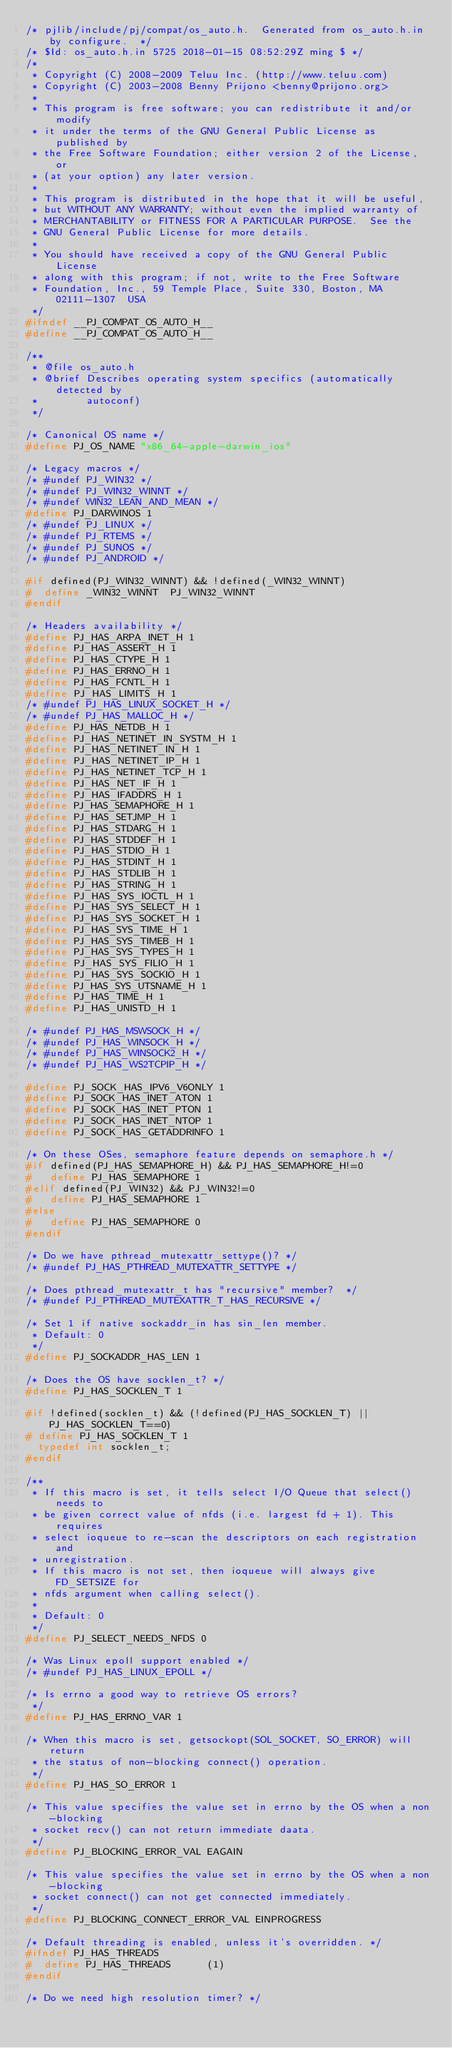<code> <loc_0><loc_0><loc_500><loc_500><_C_>/* pjlib/include/pj/compat/os_auto.h.  Generated from os_auto.h.in by configure.  */
/* $Id: os_auto.h.in 5725 2018-01-15 08:52:29Z ming $ */
/* 
 * Copyright (C) 2008-2009 Teluu Inc. (http://www.teluu.com)
 * Copyright (C) 2003-2008 Benny Prijono <benny@prijono.org>
 *
 * This program is free software; you can redistribute it and/or modify
 * it under the terms of the GNU General Public License as published by
 * the Free Software Foundation; either version 2 of the License, or
 * (at your option) any later version.
 *
 * This program is distributed in the hope that it will be useful,
 * but WITHOUT ANY WARRANTY; without even the implied warranty of
 * MERCHANTABILITY or FITNESS FOR A PARTICULAR PURPOSE.  See the
 * GNU General Public License for more details.
 *
 * You should have received a copy of the GNU General Public License
 * along with this program; if not, write to the Free Software
 * Foundation, Inc., 59 Temple Place, Suite 330, Boston, MA  02111-1307  USA 
 */
#ifndef __PJ_COMPAT_OS_AUTO_H__
#define __PJ_COMPAT_OS_AUTO_H__

/**
 * @file os_auto.h
 * @brief Describes operating system specifics (automatically detected by
 *        autoconf)
 */

/* Canonical OS name */
#define PJ_OS_NAME "x86_64-apple-darwin_ios"

/* Legacy macros */
/* #undef PJ_WIN32 */
/* #undef PJ_WIN32_WINNT */
/* #undef WIN32_LEAN_AND_MEAN */
#define PJ_DARWINOS 1
/* #undef PJ_LINUX */
/* #undef PJ_RTEMS */
/* #undef PJ_SUNOS */
/* #undef PJ_ANDROID */

#if defined(PJ_WIN32_WINNT) && !defined(_WIN32_WINNT)
#  define _WIN32_WINNT	PJ_WIN32_WINNT
#endif

/* Headers availability */
#define PJ_HAS_ARPA_INET_H 1
#define PJ_HAS_ASSERT_H 1
#define PJ_HAS_CTYPE_H 1
#define PJ_HAS_ERRNO_H 1
#define PJ_HAS_FCNTL_H 1
#define PJ_HAS_LIMITS_H 1
/* #undef PJ_HAS_LINUX_SOCKET_H */
/* #undef PJ_HAS_MALLOC_H */
#define PJ_HAS_NETDB_H 1
#define PJ_HAS_NETINET_IN_SYSTM_H 1
#define PJ_HAS_NETINET_IN_H 1
#define PJ_HAS_NETINET_IP_H 1
#define PJ_HAS_NETINET_TCP_H 1
#define PJ_HAS_NET_IF_H 1
#define PJ_HAS_IFADDRS_H 1
#define PJ_HAS_SEMAPHORE_H 1
#define PJ_HAS_SETJMP_H 1
#define PJ_HAS_STDARG_H 1
#define PJ_HAS_STDDEF_H 1
#define PJ_HAS_STDIO_H 1
#define PJ_HAS_STDINT_H 1
#define PJ_HAS_STDLIB_H 1
#define PJ_HAS_STRING_H 1
#define PJ_HAS_SYS_IOCTL_H 1
#define PJ_HAS_SYS_SELECT_H 1
#define PJ_HAS_SYS_SOCKET_H 1
#define PJ_HAS_SYS_TIME_H 1
#define PJ_HAS_SYS_TIMEB_H 1
#define PJ_HAS_SYS_TYPES_H 1
#define PJ_HAS_SYS_FILIO_H 1
#define PJ_HAS_SYS_SOCKIO_H 1
#define PJ_HAS_SYS_UTSNAME_H 1
#define PJ_HAS_TIME_H 1
#define PJ_HAS_UNISTD_H 1

/* #undef PJ_HAS_MSWSOCK_H */
/* #undef PJ_HAS_WINSOCK_H */
/* #undef PJ_HAS_WINSOCK2_H */
/* #undef PJ_HAS_WS2TCPIP_H */

#define PJ_SOCK_HAS_IPV6_V6ONLY 1
#define PJ_SOCK_HAS_INET_ATON 1
#define PJ_SOCK_HAS_INET_PTON 1
#define PJ_SOCK_HAS_INET_NTOP 1
#define PJ_SOCK_HAS_GETADDRINFO 1

/* On these OSes, semaphore feature depends on semaphore.h */
#if defined(PJ_HAS_SEMAPHORE_H) && PJ_HAS_SEMAPHORE_H!=0
#   define PJ_HAS_SEMAPHORE	1
#elif defined(PJ_WIN32) && PJ_WIN32!=0
#   define PJ_HAS_SEMAPHORE	1
#else
#   define PJ_HAS_SEMAPHORE	0
#endif

/* Do we have pthread_mutexattr_settype()? */
/* #undef PJ_HAS_PTHREAD_MUTEXATTR_SETTYPE */

/* Does pthread_mutexattr_t has "recursive" member?  */
/* #undef PJ_PTHREAD_MUTEXATTR_T_HAS_RECURSIVE */

/* Set 1 if native sockaddr_in has sin_len member. 
 * Default: 0
 */
#define PJ_SOCKADDR_HAS_LEN 1

/* Does the OS have socklen_t? */
#define PJ_HAS_SOCKLEN_T 1

#if !defined(socklen_t) && (!defined(PJ_HAS_SOCKLEN_T) || PJ_HAS_SOCKLEN_T==0)
# define PJ_HAS_SOCKLEN_T 1
  typedef int socklen_t;
#endif

/**
 * If this macro is set, it tells select I/O Queue that select() needs to
 * be given correct value of nfds (i.e. largest fd + 1). This requires
 * select ioqueue to re-scan the descriptors on each registration and
 * unregistration.
 * If this macro is not set, then ioqueue will always give FD_SETSIZE for
 * nfds argument when calling select().
 *
 * Default: 0
 */
#define PJ_SELECT_NEEDS_NFDS 0

/* Was Linux epoll support enabled */
/* #undef PJ_HAS_LINUX_EPOLL */

/* Is errno a good way to retrieve OS errors?
 */
#define PJ_HAS_ERRNO_VAR 1

/* When this macro is set, getsockopt(SOL_SOCKET, SO_ERROR) will return
 * the status of non-blocking connect() operation.
 */
#define PJ_HAS_SO_ERROR 1

/* This value specifies the value set in errno by the OS when a non-blocking
 * socket recv() can not return immediate daata.
 */
#define PJ_BLOCKING_ERROR_VAL EAGAIN

/* This value specifies the value set in errno by the OS when a non-blocking
 * socket connect() can not get connected immediately.
 */
#define PJ_BLOCKING_CONNECT_ERROR_VAL EINPROGRESS

/* Default threading is enabled, unless it's overridden. */
#ifndef PJ_HAS_THREADS
#  define PJ_HAS_THREADS	    (1)
#endif

/* Do we need high resolution timer? */</code> 